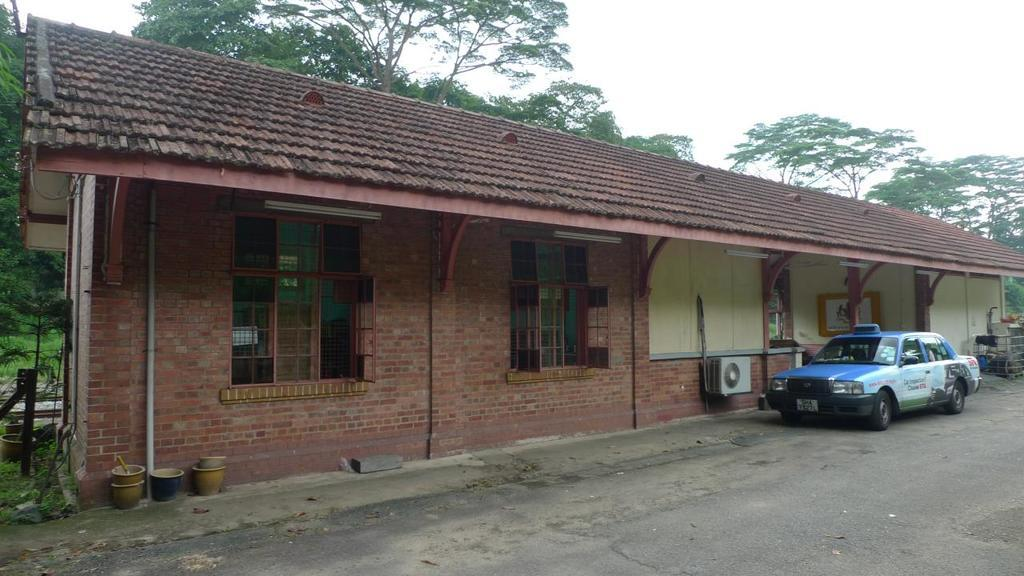What type of structure is present in the image? There is a house in the image. What is the color of the house? The house is brick in color. What else can be seen beside the house? There is a vehicle beside the house. What can be seen in the background of the image? There are trees in the background of the image. What type of soup is being served at the attraction in the image? There is no soup or attraction present in the image; it features a house with a vehicle beside it and trees in the background. 